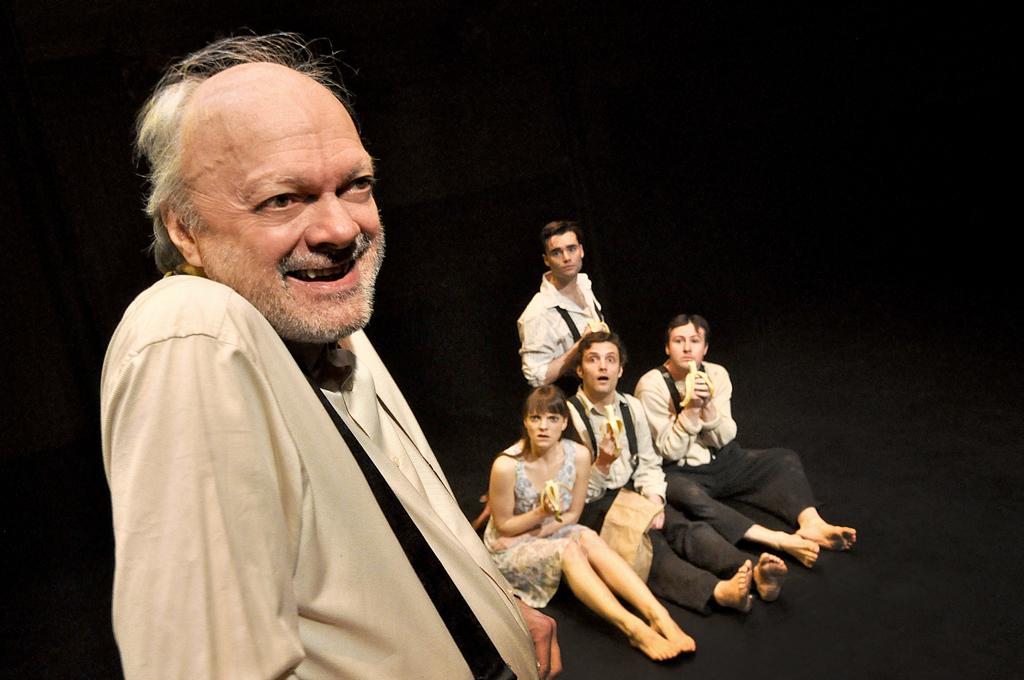What is the gender of the person on the left side of the image? There is a man on the left side of the image. How many children are in the center of the image? There are three boys in the center of the image, along with a girl. What are the boys and the girl doing in the image? The boys and the girl are eating bananas. What type of wool is the yak wearing in the image? There is no yak or wool present in the image; it features a man, three boys, and a girl eating bananas. 